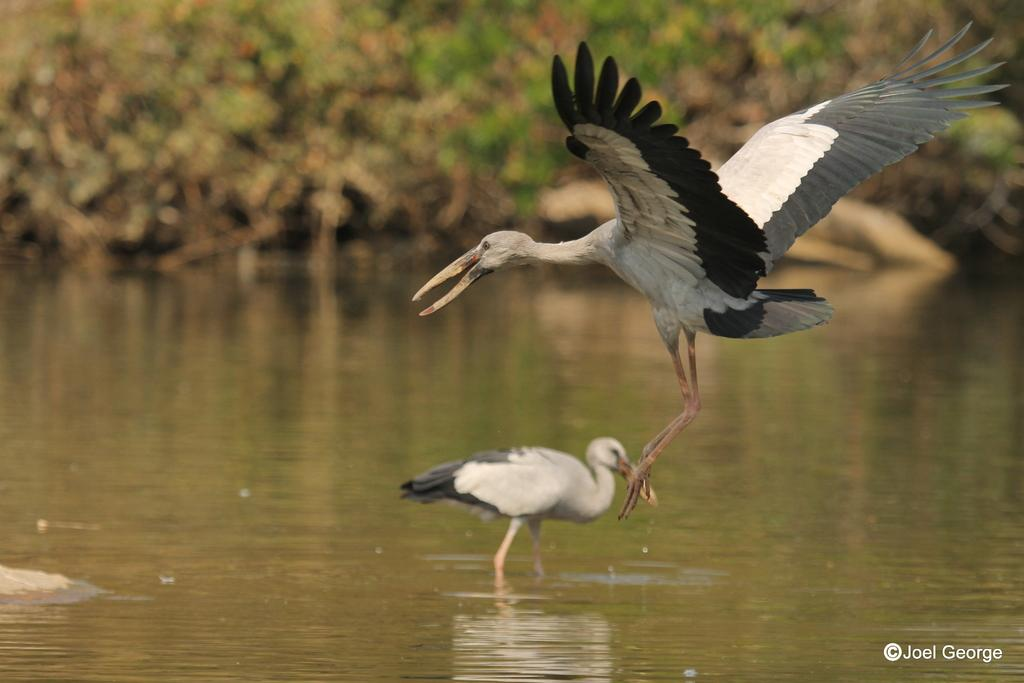What is located in the center of the image? There are birds in the center of the image. What is at the bottom of the image? There is water at the bottom of the image. What can be seen in the background of the image? There are trees in the background of the image. How many vases are present in the image? There are no vases present in the image. What type of beds can be seen in the image? There are no beds present in the image. 